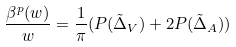Convert formula to latex. <formula><loc_0><loc_0><loc_500><loc_500>\frac { \beta ^ { p } ( w ) } { w } = \frac { 1 } { \pi } ( P ( \tilde { \Delta } _ { V } ) + 2 P ( \tilde { \Delta } _ { A } ) )</formula> 